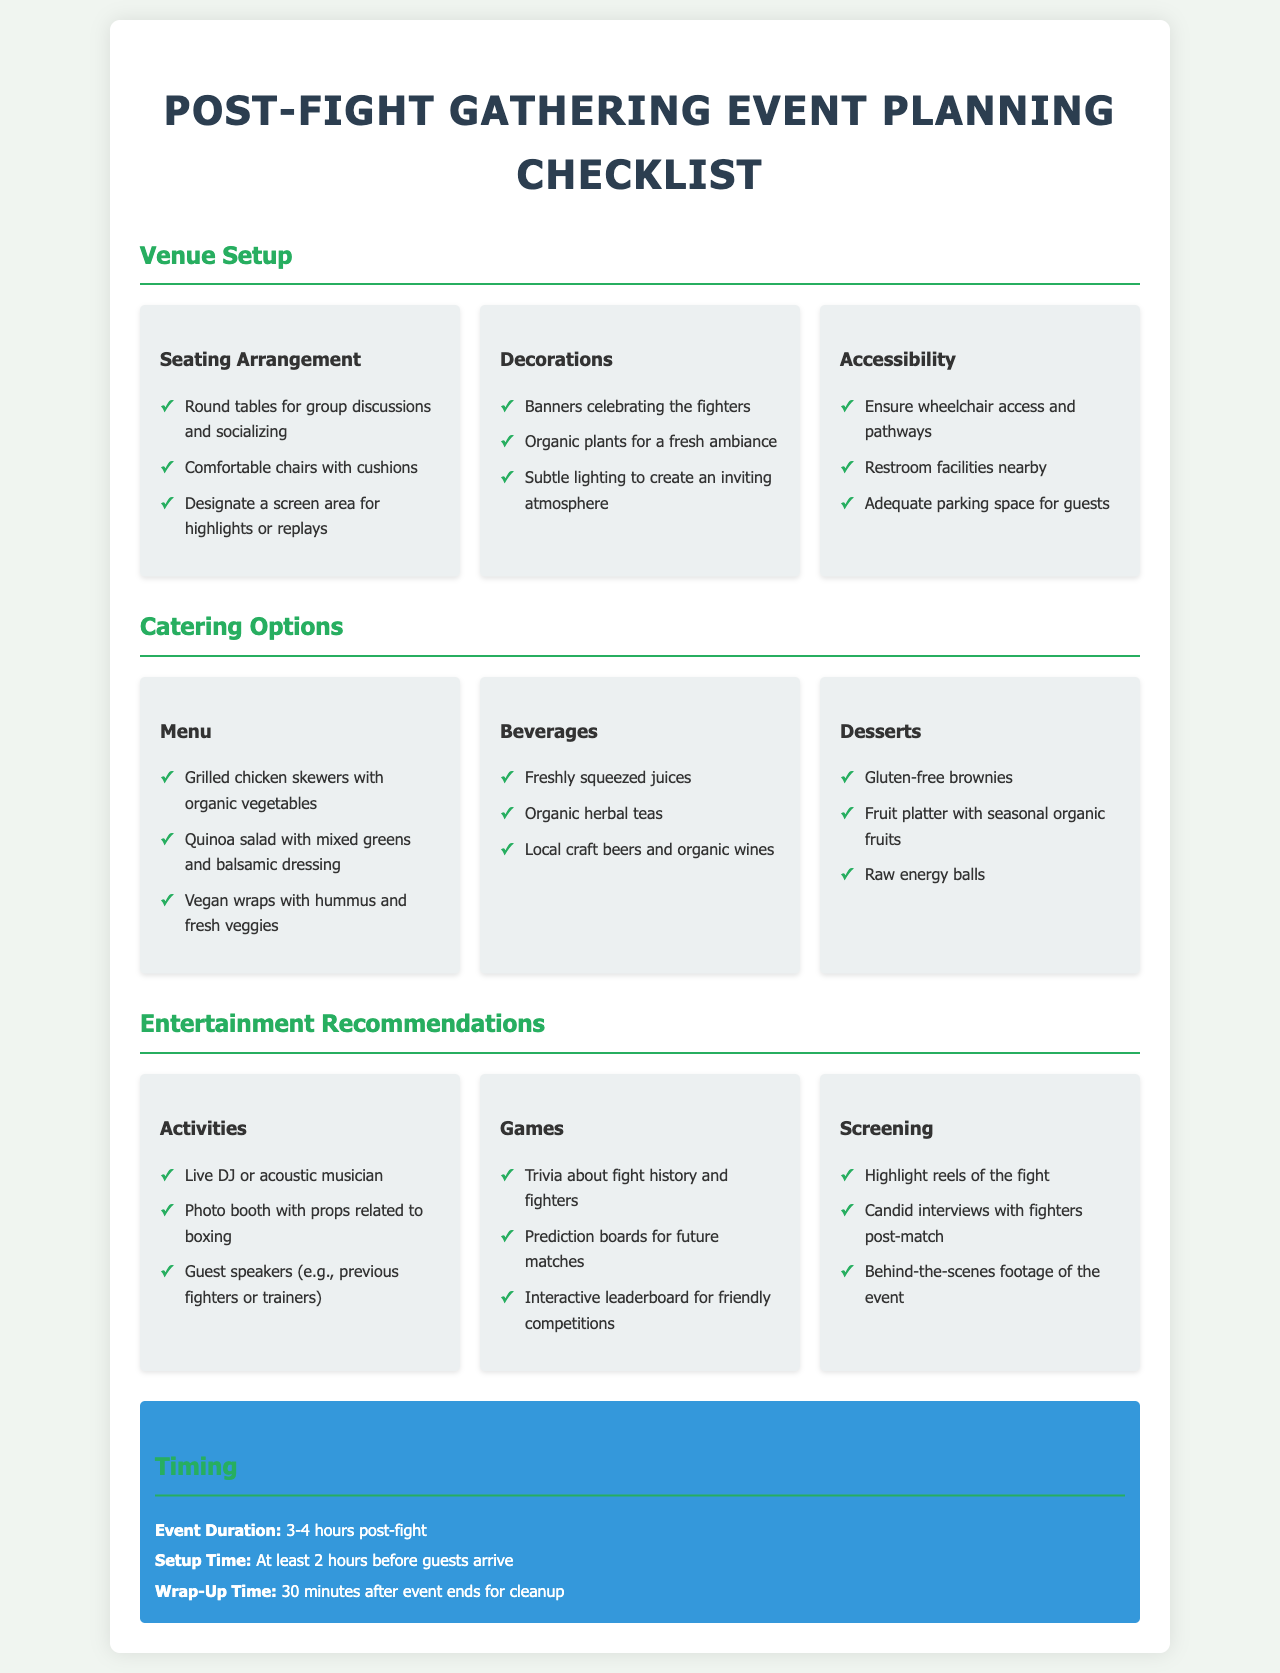What types of seating arrangements are suggested? The seating arrangements recommended in the document include round tables for group discussions and socializing.
Answer: Round tables What is the duration of the event? The document specifies that the event duration should be 3-4 hours post-fight.
Answer: 3-4 hours What are the recommended beverages? The recommended beverages include freshly squeezed juices, organic herbal teas, and local craft beers.
Answer: Freshly squeezed juices, organic herbal teas, local craft beers Which type of desserts are included in the catering options? The document lists gluten-free brownies, fruit platters, and raw energy balls as dessert options.
Answer: Gluten-free brownies, fruit platter, raw energy balls What type of entertainment is recommended for guest speakers? The document suggests inviting previous fighters or trainers as guest speakers for entertainment.
Answer: Previous fighters or trainers What is the recommended setup time before guests arrive? The document indicates that setup should take at least 2 hours before guests arrive.
Answer: 2 hours What are two suggested activities for entertainment? The document recommends live DJ or acoustic musician, along with a photo booth with props related to boxing.
Answer: Live DJ, photo booth What type of screening is suggested post-fight? The document suggests screening highlight reels of the fight as part of the entertainment recommendations.
Answer: Highlight reels of the fight 